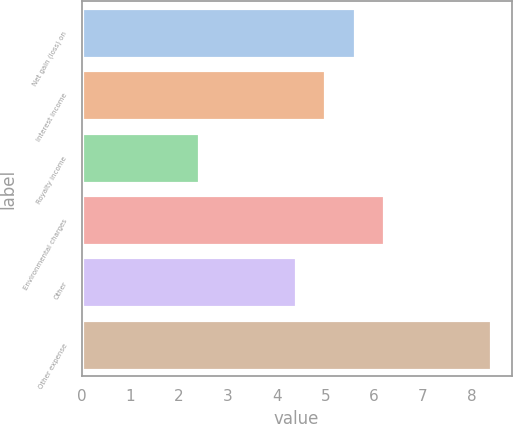Convert chart to OTSL. <chart><loc_0><loc_0><loc_500><loc_500><bar_chart><fcel>Net gain (loss) on<fcel>Interest income<fcel>Royalty income<fcel>Environmental charges<fcel>Other<fcel>Other expense<nl><fcel>5.6<fcel>5<fcel>2.4<fcel>6.2<fcel>4.4<fcel>8.4<nl></chart> 